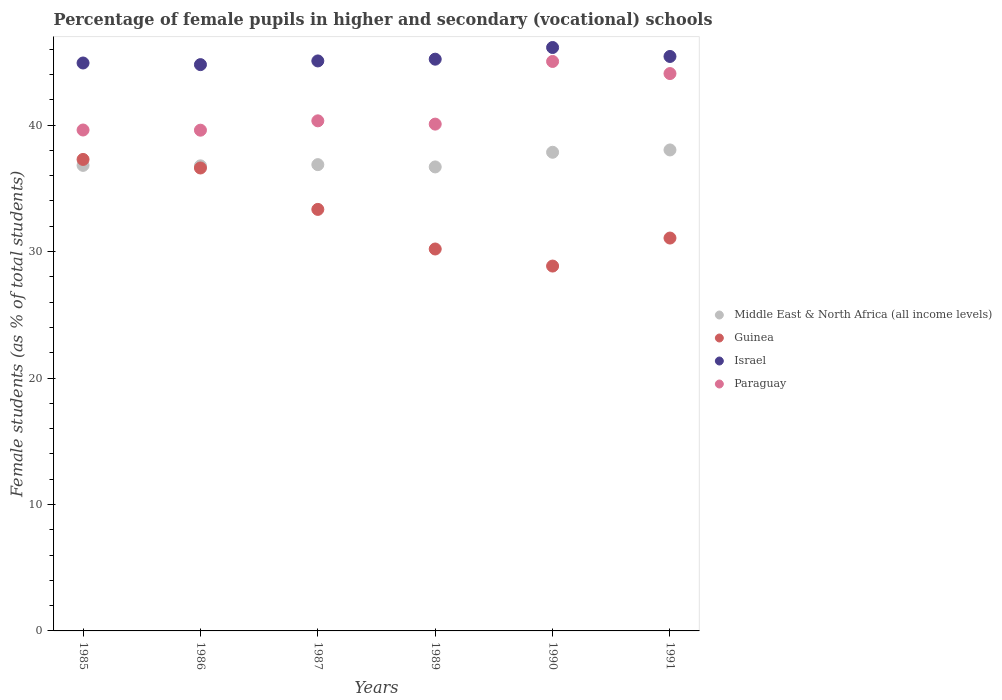What is the percentage of female pupils in higher and secondary schools in Paraguay in 1989?
Your answer should be very brief. 40.08. Across all years, what is the maximum percentage of female pupils in higher and secondary schools in Israel?
Keep it short and to the point. 46.14. Across all years, what is the minimum percentage of female pupils in higher and secondary schools in Middle East & North Africa (all income levels)?
Provide a short and direct response. 36.69. In which year was the percentage of female pupils in higher and secondary schools in Israel minimum?
Your answer should be compact. 1986. What is the total percentage of female pupils in higher and secondary schools in Middle East & North Africa (all income levels) in the graph?
Keep it short and to the point. 223.04. What is the difference between the percentage of female pupils in higher and secondary schools in Paraguay in 1987 and that in 1991?
Your response must be concise. -3.74. What is the difference between the percentage of female pupils in higher and secondary schools in Israel in 1990 and the percentage of female pupils in higher and secondary schools in Guinea in 1987?
Offer a very short reply. 12.8. What is the average percentage of female pupils in higher and secondary schools in Paraguay per year?
Keep it short and to the point. 41.46. In the year 1987, what is the difference between the percentage of female pupils in higher and secondary schools in Guinea and percentage of female pupils in higher and secondary schools in Israel?
Your response must be concise. -11.74. What is the ratio of the percentage of female pupils in higher and secondary schools in Guinea in 1985 to that in 1991?
Make the answer very short. 1.2. What is the difference between the highest and the second highest percentage of female pupils in higher and secondary schools in Israel?
Provide a short and direct response. 0.71. What is the difference between the highest and the lowest percentage of female pupils in higher and secondary schools in Guinea?
Provide a succinct answer. 8.43. In how many years, is the percentage of female pupils in higher and secondary schools in Guinea greater than the average percentage of female pupils in higher and secondary schools in Guinea taken over all years?
Your answer should be compact. 3. Is it the case that in every year, the sum of the percentage of female pupils in higher and secondary schools in Guinea and percentage of female pupils in higher and secondary schools in Israel  is greater than the sum of percentage of female pupils in higher and secondary schools in Paraguay and percentage of female pupils in higher and secondary schools in Middle East & North Africa (all income levels)?
Give a very brief answer. No. Does the percentage of female pupils in higher and secondary schools in Israel monotonically increase over the years?
Give a very brief answer. No. How many dotlines are there?
Provide a short and direct response. 4. How many years are there in the graph?
Your answer should be compact. 6. What is the difference between two consecutive major ticks on the Y-axis?
Your response must be concise. 10. Are the values on the major ticks of Y-axis written in scientific E-notation?
Offer a terse response. No. Does the graph contain any zero values?
Make the answer very short. No. What is the title of the graph?
Provide a succinct answer. Percentage of female pupils in higher and secondary (vocational) schools. Does "Vietnam" appear as one of the legend labels in the graph?
Ensure brevity in your answer.  No. What is the label or title of the Y-axis?
Keep it short and to the point. Female students (as % of total students). What is the Female students (as % of total students) in Middle East & North Africa (all income levels) in 1985?
Offer a terse response. 36.81. What is the Female students (as % of total students) in Guinea in 1985?
Keep it short and to the point. 37.28. What is the Female students (as % of total students) of Israel in 1985?
Give a very brief answer. 44.91. What is the Female students (as % of total students) in Paraguay in 1985?
Offer a very short reply. 39.61. What is the Female students (as % of total students) in Middle East & North Africa (all income levels) in 1986?
Ensure brevity in your answer.  36.78. What is the Female students (as % of total students) of Guinea in 1986?
Your answer should be compact. 36.61. What is the Female students (as % of total students) of Israel in 1986?
Make the answer very short. 44.78. What is the Female students (as % of total students) of Paraguay in 1986?
Ensure brevity in your answer.  39.6. What is the Female students (as % of total students) of Middle East & North Africa (all income levels) in 1987?
Offer a very short reply. 36.87. What is the Female students (as % of total students) in Guinea in 1987?
Your answer should be very brief. 33.33. What is the Female students (as % of total students) in Israel in 1987?
Provide a succinct answer. 45.07. What is the Female students (as % of total students) in Paraguay in 1987?
Provide a succinct answer. 40.34. What is the Female students (as % of total students) in Middle East & North Africa (all income levels) in 1989?
Ensure brevity in your answer.  36.69. What is the Female students (as % of total students) in Guinea in 1989?
Ensure brevity in your answer.  30.2. What is the Female students (as % of total students) in Israel in 1989?
Provide a succinct answer. 45.21. What is the Female students (as % of total students) in Paraguay in 1989?
Your response must be concise. 40.08. What is the Female students (as % of total students) of Middle East & North Africa (all income levels) in 1990?
Provide a short and direct response. 37.85. What is the Female students (as % of total students) of Guinea in 1990?
Give a very brief answer. 28.85. What is the Female students (as % of total students) of Israel in 1990?
Your answer should be compact. 46.14. What is the Female students (as % of total students) in Paraguay in 1990?
Ensure brevity in your answer.  45.03. What is the Female students (as % of total students) of Middle East & North Africa (all income levels) in 1991?
Provide a succinct answer. 38.03. What is the Female students (as % of total students) in Guinea in 1991?
Make the answer very short. 31.07. What is the Female students (as % of total students) in Israel in 1991?
Your answer should be compact. 45.43. What is the Female students (as % of total students) in Paraguay in 1991?
Make the answer very short. 44.08. Across all years, what is the maximum Female students (as % of total students) in Middle East & North Africa (all income levels)?
Provide a short and direct response. 38.03. Across all years, what is the maximum Female students (as % of total students) in Guinea?
Your answer should be very brief. 37.28. Across all years, what is the maximum Female students (as % of total students) of Israel?
Give a very brief answer. 46.14. Across all years, what is the maximum Female students (as % of total students) in Paraguay?
Your response must be concise. 45.03. Across all years, what is the minimum Female students (as % of total students) of Middle East & North Africa (all income levels)?
Provide a short and direct response. 36.69. Across all years, what is the minimum Female students (as % of total students) in Guinea?
Ensure brevity in your answer.  28.85. Across all years, what is the minimum Female students (as % of total students) of Israel?
Offer a very short reply. 44.78. Across all years, what is the minimum Female students (as % of total students) of Paraguay?
Keep it short and to the point. 39.6. What is the total Female students (as % of total students) in Middle East & North Africa (all income levels) in the graph?
Make the answer very short. 223.04. What is the total Female students (as % of total students) in Guinea in the graph?
Your answer should be compact. 197.35. What is the total Female students (as % of total students) in Israel in the graph?
Keep it short and to the point. 271.54. What is the total Female students (as % of total students) of Paraguay in the graph?
Make the answer very short. 248.73. What is the difference between the Female students (as % of total students) of Middle East & North Africa (all income levels) in 1985 and that in 1986?
Your answer should be very brief. 0.04. What is the difference between the Female students (as % of total students) of Guinea in 1985 and that in 1986?
Make the answer very short. 0.68. What is the difference between the Female students (as % of total students) of Israel in 1985 and that in 1986?
Offer a very short reply. 0.13. What is the difference between the Female students (as % of total students) in Paraguay in 1985 and that in 1986?
Keep it short and to the point. 0.01. What is the difference between the Female students (as % of total students) in Middle East & North Africa (all income levels) in 1985 and that in 1987?
Your answer should be compact. -0.06. What is the difference between the Female students (as % of total students) of Guinea in 1985 and that in 1987?
Your answer should be very brief. 3.95. What is the difference between the Female students (as % of total students) of Israel in 1985 and that in 1987?
Make the answer very short. -0.16. What is the difference between the Female students (as % of total students) in Paraguay in 1985 and that in 1987?
Ensure brevity in your answer.  -0.72. What is the difference between the Female students (as % of total students) in Middle East & North Africa (all income levels) in 1985 and that in 1989?
Provide a short and direct response. 0.12. What is the difference between the Female students (as % of total students) in Guinea in 1985 and that in 1989?
Provide a succinct answer. 7.08. What is the difference between the Female students (as % of total students) in Israel in 1985 and that in 1989?
Provide a short and direct response. -0.3. What is the difference between the Female students (as % of total students) of Paraguay in 1985 and that in 1989?
Give a very brief answer. -0.47. What is the difference between the Female students (as % of total students) in Middle East & North Africa (all income levels) in 1985 and that in 1990?
Give a very brief answer. -1.04. What is the difference between the Female students (as % of total students) of Guinea in 1985 and that in 1990?
Give a very brief answer. 8.43. What is the difference between the Female students (as % of total students) in Israel in 1985 and that in 1990?
Provide a short and direct response. -1.23. What is the difference between the Female students (as % of total students) in Paraguay in 1985 and that in 1990?
Give a very brief answer. -5.42. What is the difference between the Female students (as % of total students) in Middle East & North Africa (all income levels) in 1985 and that in 1991?
Give a very brief answer. -1.22. What is the difference between the Female students (as % of total students) in Guinea in 1985 and that in 1991?
Your answer should be very brief. 6.22. What is the difference between the Female students (as % of total students) in Israel in 1985 and that in 1991?
Make the answer very short. -0.52. What is the difference between the Female students (as % of total students) in Paraguay in 1985 and that in 1991?
Provide a succinct answer. -4.46. What is the difference between the Female students (as % of total students) of Middle East & North Africa (all income levels) in 1986 and that in 1987?
Provide a short and direct response. -0.1. What is the difference between the Female students (as % of total students) in Guinea in 1986 and that in 1987?
Provide a succinct answer. 3.27. What is the difference between the Female students (as % of total students) in Israel in 1986 and that in 1987?
Your answer should be very brief. -0.29. What is the difference between the Female students (as % of total students) in Paraguay in 1986 and that in 1987?
Offer a terse response. -0.74. What is the difference between the Female students (as % of total students) in Middle East & North Africa (all income levels) in 1986 and that in 1989?
Offer a terse response. 0.09. What is the difference between the Female students (as % of total students) of Guinea in 1986 and that in 1989?
Provide a short and direct response. 6.41. What is the difference between the Female students (as % of total students) in Israel in 1986 and that in 1989?
Ensure brevity in your answer.  -0.43. What is the difference between the Female students (as % of total students) of Paraguay in 1986 and that in 1989?
Offer a terse response. -0.48. What is the difference between the Female students (as % of total students) in Middle East & North Africa (all income levels) in 1986 and that in 1990?
Ensure brevity in your answer.  -1.07. What is the difference between the Female students (as % of total students) in Guinea in 1986 and that in 1990?
Ensure brevity in your answer.  7.76. What is the difference between the Female students (as % of total students) in Israel in 1986 and that in 1990?
Your response must be concise. -1.35. What is the difference between the Female students (as % of total students) of Paraguay in 1986 and that in 1990?
Offer a terse response. -5.43. What is the difference between the Female students (as % of total students) in Middle East & North Africa (all income levels) in 1986 and that in 1991?
Give a very brief answer. -1.26. What is the difference between the Female students (as % of total students) of Guinea in 1986 and that in 1991?
Provide a succinct answer. 5.54. What is the difference between the Female students (as % of total students) of Israel in 1986 and that in 1991?
Give a very brief answer. -0.65. What is the difference between the Female students (as % of total students) of Paraguay in 1986 and that in 1991?
Your answer should be very brief. -4.48. What is the difference between the Female students (as % of total students) in Middle East & North Africa (all income levels) in 1987 and that in 1989?
Give a very brief answer. 0.18. What is the difference between the Female students (as % of total students) of Guinea in 1987 and that in 1989?
Provide a succinct answer. 3.13. What is the difference between the Female students (as % of total students) of Israel in 1987 and that in 1989?
Your answer should be very brief. -0.14. What is the difference between the Female students (as % of total students) of Paraguay in 1987 and that in 1989?
Provide a short and direct response. 0.26. What is the difference between the Female students (as % of total students) in Middle East & North Africa (all income levels) in 1987 and that in 1990?
Give a very brief answer. -0.98. What is the difference between the Female students (as % of total students) in Guinea in 1987 and that in 1990?
Keep it short and to the point. 4.48. What is the difference between the Female students (as % of total students) of Israel in 1987 and that in 1990?
Offer a very short reply. -1.06. What is the difference between the Female students (as % of total students) of Paraguay in 1987 and that in 1990?
Give a very brief answer. -4.7. What is the difference between the Female students (as % of total students) in Middle East & North Africa (all income levels) in 1987 and that in 1991?
Your answer should be very brief. -1.16. What is the difference between the Female students (as % of total students) of Guinea in 1987 and that in 1991?
Provide a succinct answer. 2.27. What is the difference between the Female students (as % of total students) in Israel in 1987 and that in 1991?
Your response must be concise. -0.35. What is the difference between the Female students (as % of total students) of Paraguay in 1987 and that in 1991?
Your response must be concise. -3.74. What is the difference between the Female students (as % of total students) of Middle East & North Africa (all income levels) in 1989 and that in 1990?
Offer a very short reply. -1.16. What is the difference between the Female students (as % of total students) of Guinea in 1989 and that in 1990?
Keep it short and to the point. 1.35. What is the difference between the Female students (as % of total students) in Israel in 1989 and that in 1990?
Offer a terse response. -0.92. What is the difference between the Female students (as % of total students) of Paraguay in 1989 and that in 1990?
Give a very brief answer. -4.95. What is the difference between the Female students (as % of total students) in Middle East & North Africa (all income levels) in 1989 and that in 1991?
Offer a terse response. -1.34. What is the difference between the Female students (as % of total students) of Guinea in 1989 and that in 1991?
Keep it short and to the point. -0.87. What is the difference between the Female students (as % of total students) of Israel in 1989 and that in 1991?
Your response must be concise. -0.21. What is the difference between the Female students (as % of total students) of Paraguay in 1989 and that in 1991?
Give a very brief answer. -4. What is the difference between the Female students (as % of total students) of Middle East & North Africa (all income levels) in 1990 and that in 1991?
Offer a terse response. -0.18. What is the difference between the Female students (as % of total students) in Guinea in 1990 and that in 1991?
Ensure brevity in your answer.  -2.21. What is the difference between the Female students (as % of total students) in Israel in 1990 and that in 1991?
Your answer should be very brief. 0.71. What is the difference between the Female students (as % of total students) in Paraguay in 1990 and that in 1991?
Keep it short and to the point. 0.96. What is the difference between the Female students (as % of total students) of Middle East & North Africa (all income levels) in 1985 and the Female students (as % of total students) of Guinea in 1986?
Make the answer very short. 0.21. What is the difference between the Female students (as % of total students) of Middle East & North Africa (all income levels) in 1985 and the Female students (as % of total students) of Israel in 1986?
Your response must be concise. -7.97. What is the difference between the Female students (as % of total students) in Middle East & North Africa (all income levels) in 1985 and the Female students (as % of total students) in Paraguay in 1986?
Give a very brief answer. -2.78. What is the difference between the Female students (as % of total students) in Guinea in 1985 and the Female students (as % of total students) in Israel in 1986?
Keep it short and to the point. -7.5. What is the difference between the Female students (as % of total students) of Guinea in 1985 and the Female students (as % of total students) of Paraguay in 1986?
Offer a very short reply. -2.31. What is the difference between the Female students (as % of total students) of Israel in 1985 and the Female students (as % of total students) of Paraguay in 1986?
Make the answer very short. 5.31. What is the difference between the Female students (as % of total students) of Middle East & North Africa (all income levels) in 1985 and the Female students (as % of total students) of Guinea in 1987?
Keep it short and to the point. 3.48. What is the difference between the Female students (as % of total students) of Middle East & North Africa (all income levels) in 1985 and the Female students (as % of total students) of Israel in 1987?
Ensure brevity in your answer.  -8.26. What is the difference between the Female students (as % of total students) in Middle East & North Africa (all income levels) in 1985 and the Female students (as % of total students) in Paraguay in 1987?
Keep it short and to the point. -3.52. What is the difference between the Female students (as % of total students) of Guinea in 1985 and the Female students (as % of total students) of Israel in 1987?
Your response must be concise. -7.79. What is the difference between the Female students (as % of total students) in Guinea in 1985 and the Female students (as % of total students) in Paraguay in 1987?
Provide a succinct answer. -3.05. What is the difference between the Female students (as % of total students) of Israel in 1985 and the Female students (as % of total students) of Paraguay in 1987?
Provide a succinct answer. 4.57. What is the difference between the Female students (as % of total students) in Middle East & North Africa (all income levels) in 1985 and the Female students (as % of total students) in Guinea in 1989?
Your answer should be compact. 6.61. What is the difference between the Female students (as % of total students) of Middle East & North Africa (all income levels) in 1985 and the Female students (as % of total students) of Israel in 1989?
Make the answer very short. -8.4. What is the difference between the Female students (as % of total students) in Middle East & North Africa (all income levels) in 1985 and the Female students (as % of total students) in Paraguay in 1989?
Offer a terse response. -3.26. What is the difference between the Female students (as % of total students) of Guinea in 1985 and the Female students (as % of total students) of Israel in 1989?
Your response must be concise. -7.93. What is the difference between the Female students (as % of total students) in Guinea in 1985 and the Female students (as % of total students) in Paraguay in 1989?
Provide a succinct answer. -2.79. What is the difference between the Female students (as % of total students) of Israel in 1985 and the Female students (as % of total students) of Paraguay in 1989?
Your answer should be compact. 4.83. What is the difference between the Female students (as % of total students) of Middle East & North Africa (all income levels) in 1985 and the Female students (as % of total students) of Guinea in 1990?
Keep it short and to the point. 7.96. What is the difference between the Female students (as % of total students) of Middle East & North Africa (all income levels) in 1985 and the Female students (as % of total students) of Israel in 1990?
Ensure brevity in your answer.  -9.32. What is the difference between the Female students (as % of total students) in Middle East & North Africa (all income levels) in 1985 and the Female students (as % of total students) in Paraguay in 1990?
Your response must be concise. -8.22. What is the difference between the Female students (as % of total students) of Guinea in 1985 and the Female students (as % of total students) of Israel in 1990?
Make the answer very short. -8.85. What is the difference between the Female students (as % of total students) in Guinea in 1985 and the Female students (as % of total students) in Paraguay in 1990?
Ensure brevity in your answer.  -7.75. What is the difference between the Female students (as % of total students) in Israel in 1985 and the Female students (as % of total students) in Paraguay in 1990?
Give a very brief answer. -0.12. What is the difference between the Female students (as % of total students) in Middle East & North Africa (all income levels) in 1985 and the Female students (as % of total students) in Guinea in 1991?
Your response must be concise. 5.75. What is the difference between the Female students (as % of total students) in Middle East & North Africa (all income levels) in 1985 and the Female students (as % of total students) in Israel in 1991?
Make the answer very short. -8.61. What is the difference between the Female students (as % of total students) of Middle East & North Africa (all income levels) in 1985 and the Female students (as % of total students) of Paraguay in 1991?
Keep it short and to the point. -7.26. What is the difference between the Female students (as % of total students) in Guinea in 1985 and the Female students (as % of total students) in Israel in 1991?
Ensure brevity in your answer.  -8.14. What is the difference between the Female students (as % of total students) in Guinea in 1985 and the Female students (as % of total students) in Paraguay in 1991?
Provide a succinct answer. -6.79. What is the difference between the Female students (as % of total students) of Israel in 1985 and the Female students (as % of total students) of Paraguay in 1991?
Offer a very short reply. 0.84. What is the difference between the Female students (as % of total students) in Middle East & North Africa (all income levels) in 1986 and the Female students (as % of total students) in Guinea in 1987?
Your response must be concise. 3.44. What is the difference between the Female students (as % of total students) of Middle East & North Africa (all income levels) in 1986 and the Female students (as % of total students) of Israel in 1987?
Your answer should be very brief. -8.3. What is the difference between the Female students (as % of total students) in Middle East & North Africa (all income levels) in 1986 and the Female students (as % of total students) in Paraguay in 1987?
Keep it short and to the point. -3.56. What is the difference between the Female students (as % of total students) in Guinea in 1986 and the Female students (as % of total students) in Israel in 1987?
Make the answer very short. -8.47. What is the difference between the Female students (as % of total students) in Guinea in 1986 and the Female students (as % of total students) in Paraguay in 1987?
Your answer should be very brief. -3.73. What is the difference between the Female students (as % of total students) of Israel in 1986 and the Female students (as % of total students) of Paraguay in 1987?
Your answer should be compact. 4.44. What is the difference between the Female students (as % of total students) of Middle East & North Africa (all income levels) in 1986 and the Female students (as % of total students) of Guinea in 1989?
Your answer should be very brief. 6.58. What is the difference between the Female students (as % of total students) in Middle East & North Africa (all income levels) in 1986 and the Female students (as % of total students) in Israel in 1989?
Your answer should be compact. -8.44. What is the difference between the Female students (as % of total students) in Middle East & North Africa (all income levels) in 1986 and the Female students (as % of total students) in Paraguay in 1989?
Offer a very short reply. -3.3. What is the difference between the Female students (as % of total students) of Guinea in 1986 and the Female students (as % of total students) of Israel in 1989?
Offer a terse response. -8.6. What is the difference between the Female students (as % of total students) of Guinea in 1986 and the Female students (as % of total students) of Paraguay in 1989?
Make the answer very short. -3.47. What is the difference between the Female students (as % of total students) of Israel in 1986 and the Female students (as % of total students) of Paraguay in 1989?
Your response must be concise. 4.7. What is the difference between the Female students (as % of total students) in Middle East & North Africa (all income levels) in 1986 and the Female students (as % of total students) in Guinea in 1990?
Ensure brevity in your answer.  7.92. What is the difference between the Female students (as % of total students) of Middle East & North Africa (all income levels) in 1986 and the Female students (as % of total students) of Israel in 1990?
Your answer should be very brief. -9.36. What is the difference between the Female students (as % of total students) in Middle East & North Africa (all income levels) in 1986 and the Female students (as % of total students) in Paraguay in 1990?
Your answer should be very brief. -8.25. What is the difference between the Female students (as % of total students) in Guinea in 1986 and the Female students (as % of total students) in Israel in 1990?
Give a very brief answer. -9.53. What is the difference between the Female students (as % of total students) of Guinea in 1986 and the Female students (as % of total students) of Paraguay in 1990?
Make the answer very short. -8.42. What is the difference between the Female students (as % of total students) of Israel in 1986 and the Female students (as % of total students) of Paraguay in 1990?
Your answer should be compact. -0.25. What is the difference between the Female students (as % of total students) of Middle East & North Africa (all income levels) in 1986 and the Female students (as % of total students) of Guinea in 1991?
Make the answer very short. 5.71. What is the difference between the Female students (as % of total students) in Middle East & North Africa (all income levels) in 1986 and the Female students (as % of total students) in Israel in 1991?
Your response must be concise. -8.65. What is the difference between the Female students (as % of total students) in Middle East & North Africa (all income levels) in 1986 and the Female students (as % of total students) in Paraguay in 1991?
Offer a very short reply. -7.3. What is the difference between the Female students (as % of total students) in Guinea in 1986 and the Female students (as % of total students) in Israel in 1991?
Ensure brevity in your answer.  -8.82. What is the difference between the Female students (as % of total students) in Guinea in 1986 and the Female students (as % of total students) in Paraguay in 1991?
Your answer should be compact. -7.47. What is the difference between the Female students (as % of total students) in Israel in 1986 and the Female students (as % of total students) in Paraguay in 1991?
Offer a very short reply. 0.71. What is the difference between the Female students (as % of total students) in Middle East & North Africa (all income levels) in 1987 and the Female students (as % of total students) in Guinea in 1989?
Provide a succinct answer. 6.67. What is the difference between the Female students (as % of total students) of Middle East & North Africa (all income levels) in 1987 and the Female students (as % of total students) of Israel in 1989?
Offer a terse response. -8.34. What is the difference between the Female students (as % of total students) in Middle East & North Africa (all income levels) in 1987 and the Female students (as % of total students) in Paraguay in 1989?
Offer a terse response. -3.2. What is the difference between the Female students (as % of total students) of Guinea in 1987 and the Female students (as % of total students) of Israel in 1989?
Make the answer very short. -11.88. What is the difference between the Female students (as % of total students) of Guinea in 1987 and the Female students (as % of total students) of Paraguay in 1989?
Provide a succinct answer. -6.74. What is the difference between the Female students (as % of total students) of Israel in 1987 and the Female students (as % of total students) of Paraguay in 1989?
Keep it short and to the point. 5. What is the difference between the Female students (as % of total students) of Middle East & North Africa (all income levels) in 1987 and the Female students (as % of total students) of Guinea in 1990?
Your answer should be compact. 8.02. What is the difference between the Female students (as % of total students) in Middle East & North Africa (all income levels) in 1987 and the Female students (as % of total students) in Israel in 1990?
Provide a succinct answer. -9.26. What is the difference between the Female students (as % of total students) in Middle East & North Africa (all income levels) in 1987 and the Female students (as % of total students) in Paraguay in 1990?
Your response must be concise. -8.16. What is the difference between the Female students (as % of total students) of Guinea in 1987 and the Female students (as % of total students) of Israel in 1990?
Your response must be concise. -12.8. What is the difference between the Female students (as % of total students) in Guinea in 1987 and the Female students (as % of total students) in Paraguay in 1990?
Provide a short and direct response. -11.7. What is the difference between the Female students (as % of total students) of Israel in 1987 and the Female students (as % of total students) of Paraguay in 1990?
Offer a terse response. 0.04. What is the difference between the Female students (as % of total students) in Middle East & North Africa (all income levels) in 1987 and the Female students (as % of total students) in Guinea in 1991?
Ensure brevity in your answer.  5.81. What is the difference between the Female students (as % of total students) of Middle East & North Africa (all income levels) in 1987 and the Female students (as % of total students) of Israel in 1991?
Your answer should be compact. -8.55. What is the difference between the Female students (as % of total students) in Middle East & North Africa (all income levels) in 1987 and the Female students (as % of total students) in Paraguay in 1991?
Provide a short and direct response. -7.2. What is the difference between the Female students (as % of total students) of Guinea in 1987 and the Female students (as % of total students) of Israel in 1991?
Give a very brief answer. -12.09. What is the difference between the Female students (as % of total students) in Guinea in 1987 and the Female students (as % of total students) in Paraguay in 1991?
Keep it short and to the point. -10.74. What is the difference between the Female students (as % of total students) of Israel in 1987 and the Female students (as % of total students) of Paraguay in 1991?
Ensure brevity in your answer.  1. What is the difference between the Female students (as % of total students) of Middle East & North Africa (all income levels) in 1989 and the Female students (as % of total students) of Guinea in 1990?
Your answer should be very brief. 7.84. What is the difference between the Female students (as % of total students) in Middle East & North Africa (all income levels) in 1989 and the Female students (as % of total students) in Israel in 1990?
Provide a short and direct response. -9.44. What is the difference between the Female students (as % of total students) of Middle East & North Africa (all income levels) in 1989 and the Female students (as % of total students) of Paraguay in 1990?
Make the answer very short. -8.34. What is the difference between the Female students (as % of total students) of Guinea in 1989 and the Female students (as % of total students) of Israel in 1990?
Offer a very short reply. -15.93. What is the difference between the Female students (as % of total students) in Guinea in 1989 and the Female students (as % of total students) in Paraguay in 1990?
Your answer should be very brief. -14.83. What is the difference between the Female students (as % of total students) of Israel in 1989 and the Female students (as % of total students) of Paraguay in 1990?
Your answer should be very brief. 0.18. What is the difference between the Female students (as % of total students) of Middle East & North Africa (all income levels) in 1989 and the Female students (as % of total students) of Guinea in 1991?
Provide a succinct answer. 5.62. What is the difference between the Female students (as % of total students) of Middle East & North Africa (all income levels) in 1989 and the Female students (as % of total students) of Israel in 1991?
Provide a succinct answer. -8.74. What is the difference between the Female students (as % of total students) of Middle East & North Africa (all income levels) in 1989 and the Female students (as % of total students) of Paraguay in 1991?
Make the answer very short. -7.38. What is the difference between the Female students (as % of total students) in Guinea in 1989 and the Female students (as % of total students) in Israel in 1991?
Give a very brief answer. -15.23. What is the difference between the Female students (as % of total students) of Guinea in 1989 and the Female students (as % of total students) of Paraguay in 1991?
Your answer should be compact. -13.87. What is the difference between the Female students (as % of total students) of Israel in 1989 and the Female students (as % of total students) of Paraguay in 1991?
Give a very brief answer. 1.14. What is the difference between the Female students (as % of total students) in Middle East & North Africa (all income levels) in 1990 and the Female students (as % of total students) in Guinea in 1991?
Offer a terse response. 6.78. What is the difference between the Female students (as % of total students) of Middle East & North Africa (all income levels) in 1990 and the Female students (as % of total students) of Israel in 1991?
Give a very brief answer. -7.58. What is the difference between the Female students (as % of total students) in Middle East & North Africa (all income levels) in 1990 and the Female students (as % of total students) in Paraguay in 1991?
Provide a short and direct response. -6.22. What is the difference between the Female students (as % of total students) in Guinea in 1990 and the Female students (as % of total students) in Israel in 1991?
Give a very brief answer. -16.57. What is the difference between the Female students (as % of total students) of Guinea in 1990 and the Female students (as % of total students) of Paraguay in 1991?
Give a very brief answer. -15.22. What is the difference between the Female students (as % of total students) in Israel in 1990 and the Female students (as % of total students) in Paraguay in 1991?
Your response must be concise. 2.06. What is the average Female students (as % of total students) in Middle East & North Africa (all income levels) per year?
Your answer should be compact. 37.17. What is the average Female students (as % of total students) of Guinea per year?
Offer a terse response. 32.89. What is the average Female students (as % of total students) of Israel per year?
Give a very brief answer. 45.26. What is the average Female students (as % of total students) in Paraguay per year?
Offer a very short reply. 41.46. In the year 1985, what is the difference between the Female students (as % of total students) in Middle East & North Africa (all income levels) and Female students (as % of total students) in Guinea?
Your response must be concise. -0.47. In the year 1985, what is the difference between the Female students (as % of total students) of Middle East & North Africa (all income levels) and Female students (as % of total students) of Israel?
Offer a very short reply. -8.1. In the year 1985, what is the difference between the Female students (as % of total students) of Middle East & North Africa (all income levels) and Female students (as % of total students) of Paraguay?
Keep it short and to the point. -2.8. In the year 1985, what is the difference between the Female students (as % of total students) of Guinea and Female students (as % of total students) of Israel?
Your response must be concise. -7.63. In the year 1985, what is the difference between the Female students (as % of total students) of Guinea and Female students (as % of total students) of Paraguay?
Your answer should be very brief. -2.33. In the year 1985, what is the difference between the Female students (as % of total students) in Israel and Female students (as % of total students) in Paraguay?
Provide a succinct answer. 5.3. In the year 1986, what is the difference between the Female students (as % of total students) of Middle East & North Africa (all income levels) and Female students (as % of total students) of Guinea?
Your answer should be very brief. 0.17. In the year 1986, what is the difference between the Female students (as % of total students) of Middle East & North Africa (all income levels) and Female students (as % of total students) of Israel?
Make the answer very short. -8. In the year 1986, what is the difference between the Female students (as % of total students) of Middle East & North Africa (all income levels) and Female students (as % of total students) of Paraguay?
Your answer should be very brief. -2.82. In the year 1986, what is the difference between the Female students (as % of total students) in Guinea and Female students (as % of total students) in Israel?
Make the answer very short. -8.17. In the year 1986, what is the difference between the Female students (as % of total students) of Guinea and Female students (as % of total students) of Paraguay?
Your response must be concise. -2.99. In the year 1986, what is the difference between the Female students (as % of total students) of Israel and Female students (as % of total students) of Paraguay?
Your answer should be very brief. 5.18. In the year 1987, what is the difference between the Female students (as % of total students) in Middle East & North Africa (all income levels) and Female students (as % of total students) in Guinea?
Offer a very short reply. 3.54. In the year 1987, what is the difference between the Female students (as % of total students) in Middle East & North Africa (all income levels) and Female students (as % of total students) in Israel?
Offer a terse response. -8.2. In the year 1987, what is the difference between the Female students (as % of total students) in Middle East & North Africa (all income levels) and Female students (as % of total students) in Paraguay?
Keep it short and to the point. -3.46. In the year 1987, what is the difference between the Female students (as % of total students) in Guinea and Female students (as % of total students) in Israel?
Offer a very short reply. -11.74. In the year 1987, what is the difference between the Female students (as % of total students) of Guinea and Female students (as % of total students) of Paraguay?
Provide a succinct answer. -7. In the year 1987, what is the difference between the Female students (as % of total students) of Israel and Female students (as % of total students) of Paraguay?
Ensure brevity in your answer.  4.74. In the year 1989, what is the difference between the Female students (as % of total students) in Middle East & North Africa (all income levels) and Female students (as % of total students) in Guinea?
Ensure brevity in your answer.  6.49. In the year 1989, what is the difference between the Female students (as % of total students) of Middle East & North Africa (all income levels) and Female students (as % of total students) of Israel?
Give a very brief answer. -8.52. In the year 1989, what is the difference between the Female students (as % of total students) in Middle East & North Africa (all income levels) and Female students (as % of total students) in Paraguay?
Offer a terse response. -3.39. In the year 1989, what is the difference between the Female students (as % of total students) of Guinea and Female students (as % of total students) of Israel?
Provide a short and direct response. -15.01. In the year 1989, what is the difference between the Female students (as % of total students) in Guinea and Female students (as % of total students) in Paraguay?
Your answer should be compact. -9.88. In the year 1989, what is the difference between the Female students (as % of total students) of Israel and Female students (as % of total students) of Paraguay?
Your answer should be very brief. 5.14. In the year 1990, what is the difference between the Female students (as % of total students) of Middle East & North Africa (all income levels) and Female students (as % of total students) of Guinea?
Keep it short and to the point. 9. In the year 1990, what is the difference between the Female students (as % of total students) in Middle East & North Africa (all income levels) and Female students (as % of total students) in Israel?
Your answer should be very brief. -8.28. In the year 1990, what is the difference between the Female students (as % of total students) in Middle East & North Africa (all income levels) and Female students (as % of total students) in Paraguay?
Your response must be concise. -7.18. In the year 1990, what is the difference between the Female students (as % of total students) of Guinea and Female students (as % of total students) of Israel?
Your answer should be compact. -17.28. In the year 1990, what is the difference between the Female students (as % of total students) of Guinea and Female students (as % of total students) of Paraguay?
Offer a very short reply. -16.18. In the year 1990, what is the difference between the Female students (as % of total students) of Israel and Female students (as % of total students) of Paraguay?
Keep it short and to the point. 1.1. In the year 1991, what is the difference between the Female students (as % of total students) of Middle East & North Africa (all income levels) and Female students (as % of total students) of Guinea?
Provide a succinct answer. 6.97. In the year 1991, what is the difference between the Female students (as % of total students) in Middle East & North Africa (all income levels) and Female students (as % of total students) in Israel?
Your answer should be compact. -7.39. In the year 1991, what is the difference between the Female students (as % of total students) in Middle East & North Africa (all income levels) and Female students (as % of total students) in Paraguay?
Give a very brief answer. -6.04. In the year 1991, what is the difference between the Female students (as % of total students) in Guinea and Female students (as % of total students) in Israel?
Your answer should be compact. -14.36. In the year 1991, what is the difference between the Female students (as % of total students) of Guinea and Female students (as % of total students) of Paraguay?
Make the answer very short. -13.01. In the year 1991, what is the difference between the Female students (as % of total students) in Israel and Female students (as % of total students) in Paraguay?
Your response must be concise. 1.35. What is the ratio of the Female students (as % of total students) of Guinea in 1985 to that in 1986?
Offer a terse response. 1.02. What is the ratio of the Female students (as % of total students) of Israel in 1985 to that in 1986?
Keep it short and to the point. 1. What is the ratio of the Female students (as % of total students) of Paraguay in 1985 to that in 1986?
Offer a terse response. 1. What is the ratio of the Female students (as % of total students) of Guinea in 1985 to that in 1987?
Your answer should be compact. 1.12. What is the ratio of the Female students (as % of total students) of Paraguay in 1985 to that in 1987?
Make the answer very short. 0.98. What is the ratio of the Female students (as % of total students) in Guinea in 1985 to that in 1989?
Give a very brief answer. 1.23. What is the ratio of the Female students (as % of total students) in Paraguay in 1985 to that in 1989?
Your answer should be compact. 0.99. What is the ratio of the Female students (as % of total students) of Middle East & North Africa (all income levels) in 1985 to that in 1990?
Offer a terse response. 0.97. What is the ratio of the Female students (as % of total students) in Guinea in 1985 to that in 1990?
Your response must be concise. 1.29. What is the ratio of the Female students (as % of total students) of Israel in 1985 to that in 1990?
Your answer should be very brief. 0.97. What is the ratio of the Female students (as % of total students) in Paraguay in 1985 to that in 1990?
Keep it short and to the point. 0.88. What is the ratio of the Female students (as % of total students) in Middle East & North Africa (all income levels) in 1985 to that in 1991?
Provide a short and direct response. 0.97. What is the ratio of the Female students (as % of total students) of Guinea in 1985 to that in 1991?
Give a very brief answer. 1.2. What is the ratio of the Female students (as % of total students) in Paraguay in 1985 to that in 1991?
Provide a short and direct response. 0.9. What is the ratio of the Female students (as % of total students) in Middle East & North Africa (all income levels) in 1986 to that in 1987?
Provide a short and direct response. 1. What is the ratio of the Female students (as % of total students) in Guinea in 1986 to that in 1987?
Your response must be concise. 1.1. What is the ratio of the Female students (as % of total students) in Israel in 1986 to that in 1987?
Offer a very short reply. 0.99. What is the ratio of the Female students (as % of total students) in Paraguay in 1986 to that in 1987?
Make the answer very short. 0.98. What is the ratio of the Female students (as % of total students) of Middle East & North Africa (all income levels) in 1986 to that in 1989?
Your answer should be very brief. 1. What is the ratio of the Female students (as % of total students) in Guinea in 1986 to that in 1989?
Make the answer very short. 1.21. What is the ratio of the Female students (as % of total students) of Middle East & North Africa (all income levels) in 1986 to that in 1990?
Ensure brevity in your answer.  0.97. What is the ratio of the Female students (as % of total students) in Guinea in 1986 to that in 1990?
Give a very brief answer. 1.27. What is the ratio of the Female students (as % of total students) in Israel in 1986 to that in 1990?
Offer a terse response. 0.97. What is the ratio of the Female students (as % of total students) in Paraguay in 1986 to that in 1990?
Make the answer very short. 0.88. What is the ratio of the Female students (as % of total students) in Middle East & North Africa (all income levels) in 1986 to that in 1991?
Keep it short and to the point. 0.97. What is the ratio of the Female students (as % of total students) in Guinea in 1986 to that in 1991?
Your answer should be very brief. 1.18. What is the ratio of the Female students (as % of total students) in Israel in 1986 to that in 1991?
Make the answer very short. 0.99. What is the ratio of the Female students (as % of total students) in Paraguay in 1986 to that in 1991?
Your response must be concise. 0.9. What is the ratio of the Female students (as % of total students) in Guinea in 1987 to that in 1989?
Offer a very short reply. 1.1. What is the ratio of the Female students (as % of total students) of Israel in 1987 to that in 1989?
Provide a succinct answer. 1. What is the ratio of the Female students (as % of total students) in Paraguay in 1987 to that in 1989?
Keep it short and to the point. 1.01. What is the ratio of the Female students (as % of total students) in Middle East & North Africa (all income levels) in 1987 to that in 1990?
Offer a terse response. 0.97. What is the ratio of the Female students (as % of total students) in Guinea in 1987 to that in 1990?
Make the answer very short. 1.16. What is the ratio of the Female students (as % of total students) of Israel in 1987 to that in 1990?
Provide a short and direct response. 0.98. What is the ratio of the Female students (as % of total students) of Paraguay in 1987 to that in 1990?
Make the answer very short. 0.9. What is the ratio of the Female students (as % of total students) of Middle East & North Africa (all income levels) in 1987 to that in 1991?
Your response must be concise. 0.97. What is the ratio of the Female students (as % of total students) in Guinea in 1987 to that in 1991?
Provide a short and direct response. 1.07. What is the ratio of the Female students (as % of total students) in Paraguay in 1987 to that in 1991?
Provide a succinct answer. 0.92. What is the ratio of the Female students (as % of total students) of Middle East & North Africa (all income levels) in 1989 to that in 1990?
Provide a succinct answer. 0.97. What is the ratio of the Female students (as % of total students) in Guinea in 1989 to that in 1990?
Your answer should be compact. 1.05. What is the ratio of the Female students (as % of total students) in Israel in 1989 to that in 1990?
Make the answer very short. 0.98. What is the ratio of the Female students (as % of total students) in Paraguay in 1989 to that in 1990?
Give a very brief answer. 0.89. What is the ratio of the Female students (as % of total students) in Middle East & North Africa (all income levels) in 1989 to that in 1991?
Provide a succinct answer. 0.96. What is the ratio of the Female students (as % of total students) in Guinea in 1989 to that in 1991?
Make the answer very short. 0.97. What is the ratio of the Female students (as % of total students) of Paraguay in 1989 to that in 1991?
Give a very brief answer. 0.91. What is the ratio of the Female students (as % of total students) of Middle East & North Africa (all income levels) in 1990 to that in 1991?
Ensure brevity in your answer.  1. What is the ratio of the Female students (as % of total students) of Guinea in 1990 to that in 1991?
Your response must be concise. 0.93. What is the ratio of the Female students (as % of total students) in Israel in 1990 to that in 1991?
Provide a succinct answer. 1.02. What is the ratio of the Female students (as % of total students) in Paraguay in 1990 to that in 1991?
Ensure brevity in your answer.  1.02. What is the difference between the highest and the second highest Female students (as % of total students) of Middle East & North Africa (all income levels)?
Give a very brief answer. 0.18. What is the difference between the highest and the second highest Female students (as % of total students) of Guinea?
Provide a short and direct response. 0.68. What is the difference between the highest and the second highest Female students (as % of total students) in Israel?
Ensure brevity in your answer.  0.71. What is the difference between the highest and the lowest Female students (as % of total students) of Middle East & North Africa (all income levels)?
Provide a succinct answer. 1.34. What is the difference between the highest and the lowest Female students (as % of total students) in Guinea?
Your answer should be compact. 8.43. What is the difference between the highest and the lowest Female students (as % of total students) in Israel?
Offer a very short reply. 1.35. What is the difference between the highest and the lowest Female students (as % of total students) of Paraguay?
Your answer should be very brief. 5.43. 